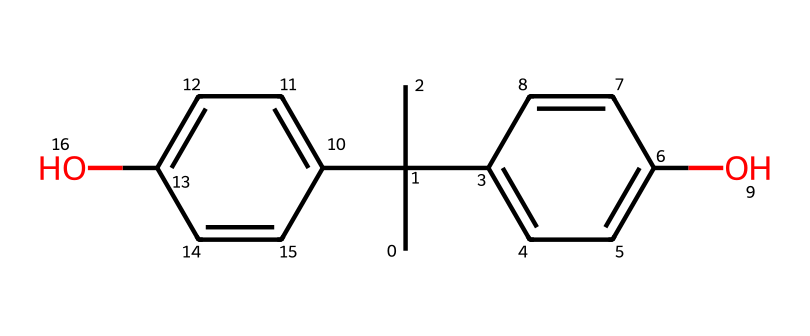What is the name of the compound represented by this SMILES? The SMILES representation corresponds to Bisphenol A, a well-known chemical compound often associated with various products including plastics and coatings. The structure has two phenolic groups connected by a central carbon atom, typical of BPA.
Answer: Bisphenol A How many carbon atoms are present in this chemical structure? By analyzing the structure derived from the SMILES, we can manually count the number of carbon atoms represented. There are 15 carbon atoms in the given structure (C).
Answer: 15 What type of functional groups can be identified in this chemical? The chemical structure contains hydroxyl (-OH) functional groups, indicated by the presence of oxygen atoms bonded to hydrogen atoms. These functional groups are evident where the phenolic rings end.
Answer: hydroxyl groups What is the total number of oxygen atoms in this chemical? From the visual breakdown of the structure, the SMILES indicates there are two hydroxyl groups, which each contribute one oxygen atom. As such, there are a total of 2 oxygen atoms in the compound.
Answer: 2 Are there any aromatic rings present in this chemical? Yes, upon analyzing the structure derived from the SMILES, there are two aromatic (phenyl) rings as the chemical is based on biphenyl. Each ring exhibits traits characteristic of aromatic compounds.
Answer: Yes Is Bisphenol A considered a hazardous chemical? Yes, Bisphenol A is classified as a hazardous chemical due to its potential endocrine-disrupting effects and has been linked to various health concerns, which is relevant to its presence in consumer products.
Answer: Yes 